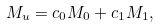<formula> <loc_0><loc_0><loc_500><loc_500>M _ { u } = c _ { 0 } M _ { 0 } + c _ { 1 } M _ { 1 } ,</formula> 